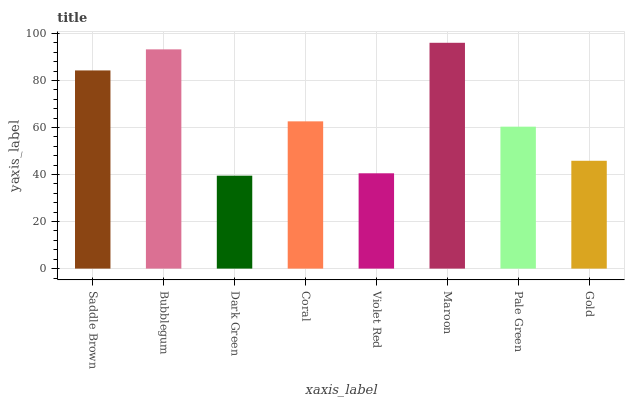Is Dark Green the minimum?
Answer yes or no. Yes. Is Maroon the maximum?
Answer yes or no. Yes. Is Bubblegum the minimum?
Answer yes or no. No. Is Bubblegum the maximum?
Answer yes or no. No. Is Bubblegum greater than Saddle Brown?
Answer yes or no. Yes. Is Saddle Brown less than Bubblegum?
Answer yes or no. Yes. Is Saddle Brown greater than Bubblegum?
Answer yes or no. No. Is Bubblegum less than Saddle Brown?
Answer yes or no. No. Is Coral the high median?
Answer yes or no. Yes. Is Pale Green the low median?
Answer yes or no. Yes. Is Maroon the high median?
Answer yes or no. No. Is Maroon the low median?
Answer yes or no. No. 